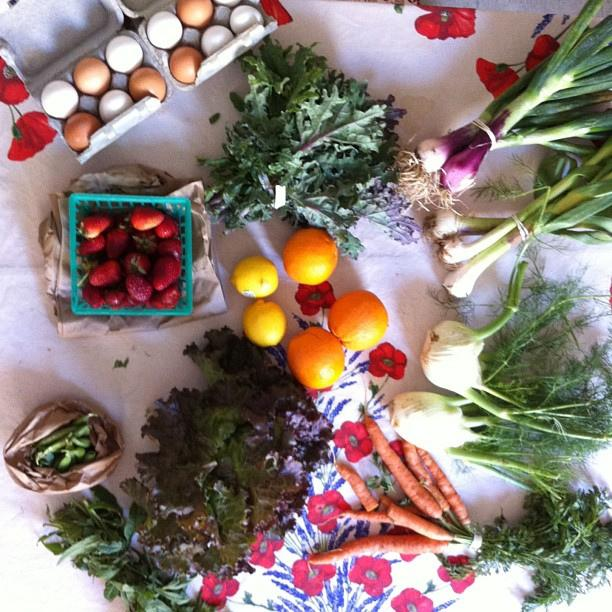What is the orange item near the bottom of the pile? Please explain your reasoning. carrot. Carrots are orange with green on top. 